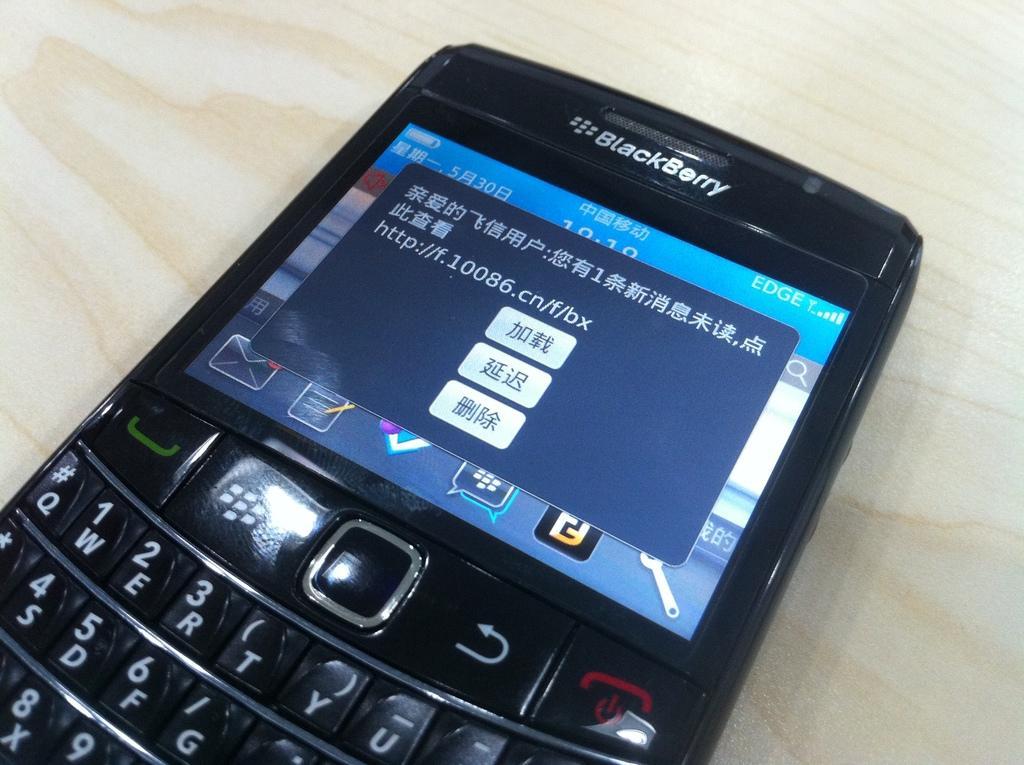In one or two sentences, can you explain what this image depicts? In this image I can see the mobile on the cream and brown color surface. 